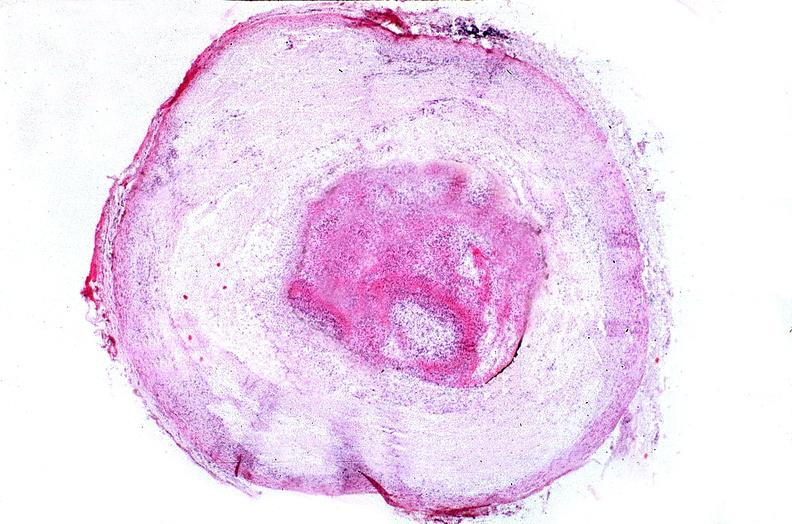s vasculature present?
Answer the question using a single word or phrase. Yes 